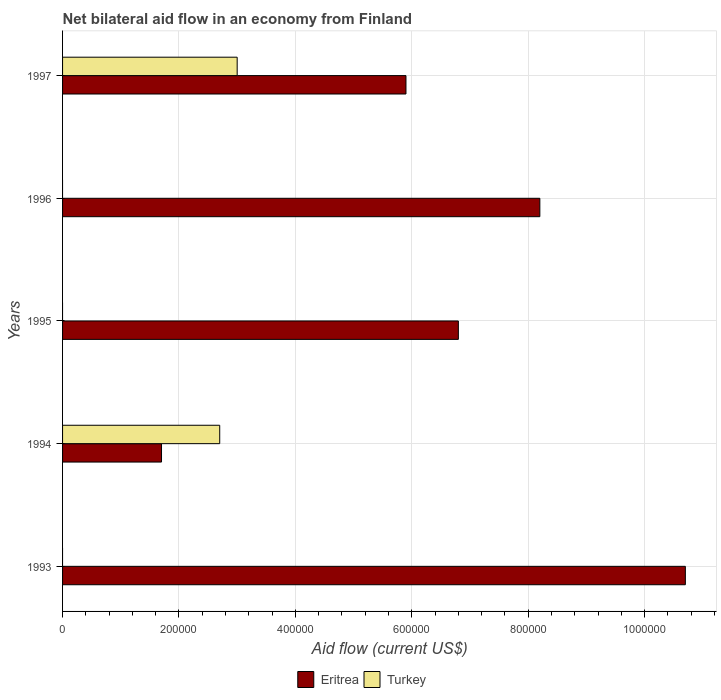Are the number of bars on each tick of the Y-axis equal?
Your answer should be compact. No. What is the label of the 1st group of bars from the top?
Provide a short and direct response. 1997. In how many cases, is the number of bars for a given year not equal to the number of legend labels?
Ensure brevity in your answer.  3. What is the net bilateral aid flow in Eritrea in 1996?
Your answer should be very brief. 8.20e+05. Across all years, what is the minimum net bilateral aid flow in Eritrea?
Your answer should be very brief. 1.70e+05. In which year was the net bilateral aid flow in Eritrea maximum?
Your response must be concise. 1993. What is the total net bilateral aid flow in Turkey in the graph?
Offer a very short reply. 5.70e+05. What is the difference between the net bilateral aid flow in Eritrea in 1993 and that in 1996?
Your response must be concise. 2.50e+05. What is the difference between the net bilateral aid flow in Turkey in 1996 and the net bilateral aid flow in Eritrea in 1997?
Ensure brevity in your answer.  -5.90e+05. What is the average net bilateral aid flow in Turkey per year?
Keep it short and to the point. 1.14e+05. In the year 1997, what is the difference between the net bilateral aid flow in Turkey and net bilateral aid flow in Eritrea?
Your response must be concise. -2.90e+05. In how many years, is the net bilateral aid flow in Turkey greater than 840000 US$?
Keep it short and to the point. 0. What is the ratio of the net bilateral aid flow in Eritrea in 1993 to that in 1995?
Offer a very short reply. 1.57. What is the difference between the highest and the second highest net bilateral aid flow in Eritrea?
Give a very brief answer. 2.50e+05. What is the difference between the highest and the lowest net bilateral aid flow in Eritrea?
Make the answer very short. 9.00e+05. In how many years, is the net bilateral aid flow in Turkey greater than the average net bilateral aid flow in Turkey taken over all years?
Provide a short and direct response. 2. How many bars are there?
Provide a succinct answer. 7. Are all the bars in the graph horizontal?
Your response must be concise. Yes. How many years are there in the graph?
Offer a terse response. 5. What is the difference between two consecutive major ticks on the X-axis?
Make the answer very short. 2.00e+05. Does the graph contain any zero values?
Your answer should be compact. Yes. Where does the legend appear in the graph?
Give a very brief answer. Bottom center. What is the title of the graph?
Provide a succinct answer. Net bilateral aid flow in an economy from Finland. What is the label or title of the Y-axis?
Your answer should be very brief. Years. What is the Aid flow (current US$) in Eritrea in 1993?
Your answer should be very brief. 1.07e+06. What is the Aid flow (current US$) in Turkey in 1993?
Provide a succinct answer. 0. What is the Aid flow (current US$) in Eritrea in 1994?
Provide a short and direct response. 1.70e+05. What is the Aid flow (current US$) in Eritrea in 1995?
Ensure brevity in your answer.  6.80e+05. What is the Aid flow (current US$) of Turkey in 1995?
Give a very brief answer. 0. What is the Aid flow (current US$) in Eritrea in 1996?
Give a very brief answer. 8.20e+05. What is the Aid flow (current US$) in Eritrea in 1997?
Keep it short and to the point. 5.90e+05. What is the Aid flow (current US$) in Turkey in 1997?
Give a very brief answer. 3.00e+05. Across all years, what is the maximum Aid flow (current US$) in Eritrea?
Offer a terse response. 1.07e+06. Across all years, what is the maximum Aid flow (current US$) in Turkey?
Make the answer very short. 3.00e+05. What is the total Aid flow (current US$) in Eritrea in the graph?
Give a very brief answer. 3.33e+06. What is the total Aid flow (current US$) of Turkey in the graph?
Provide a short and direct response. 5.70e+05. What is the difference between the Aid flow (current US$) of Eritrea in 1993 and that in 1996?
Provide a short and direct response. 2.50e+05. What is the difference between the Aid flow (current US$) of Eritrea in 1993 and that in 1997?
Provide a succinct answer. 4.80e+05. What is the difference between the Aid flow (current US$) of Eritrea in 1994 and that in 1995?
Make the answer very short. -5.10e+05. What is the difference between the Aid flow (current US$) in Eritrea in 1994 and that in 1996?
Give a very brief answer. -6.50e+05. What is the difference between the Aid flow (current US$) of Eritrea in 1994 and that in 1997?
Offer a very short reply. -4.20e+05. What is the difference between the Aid flow (current US$) of Eritrea in 1995 and that in 1996?
Offer a terse response. -1.40e+05. What is the difference between the Aid flow (current US$) of Eritrea in 1993 and the Aid flow (current US$) of Turkey in 1994?
Offer a terse response. 8.00e+05. What is the difference between the Aid flow (current US$) of Eritrea in 1993 and the Aid flow (current US$) of Turkey in 1997?
Keep it short and to the point. 7.70e+05. What is the difference between the Aid flow (current US$) in Eritrea in 1995 and the Aid flow (current US$) in Turkey in 1997?
Provide a succinct answer. 3.80e+05. What is the difference between the Aid flow (current US$) in Eritrea in 1996 and the Aid flow (current US$) in Turkey in 1997?
Provide a short and direct response. 5.20e+05. What is the average Aid flow (current US$) of Eritrea per year?
Your response must be concise. 6.66e+05. What is the average Aid flow (current US$) in Turkey per year?
Offer a very short reply. 1.14e+05. In the year 1994, what is the difference between the Aid flow (current US$) in Eritrea and Aid flow (current US$) in Turkey?
Provide a short and direct response. -1.00e+05. In the year 1997, what is the difference between the Aid flow (current US$) in Eritrea and Aid flow (current US$) in Turkey?
Offer a very short reply. 2.90e+05. What is the ratio of the Aid flow (current US$) in Eritrea in 1993 to that in 1994?
Your answer should be compact. 6.29. What is the ratio of the Aid flow (current US$) in Eritrea in 1993 to that in 1995?
Your answer should be compact. 1.57. What is the ratio of the Aid flow (current US$) of Eritrea in 1993 to that in 1996?
Give a very brief answer. 1.3. What is the ratio of the Aid flow (current US$) of Eritrea in 1993 to that in 1997?
Offer a very short reply. 1.81. What is the ratio of the Aid flow (current US$) in Eritrea in 1994 to that in 1995?
Offer a very short reply. 0.25. What is the ratio of the Aid flow (current US$) of Eritrea in 1994 to that in 1996?
Your answer should be compact. 0.21. What is the ratio of the Aid flow (current US$) of Eritrea in 1994 to that in 1997?
Your answer should be compact. 0.29. What is the ratio of the Aid flow (current US$) of Eritrea in 1995 to that in 1996?
Offer a very short reply. 0.83. What is the ratio of the Aid flow (current US$) of Eritrea in 1995 to that in 1997?
Ensure brevity in your answer.  1.15. What is the ratio of the Aid flow (current US$) of Eritrea in 1996 to that in 1997?
Offer a terse response. 1.39. What is the difference between the highest and the lowest Aid flow (current US$) in Eritrea?
Ensure brevity in your answer.  9.00e+05. 